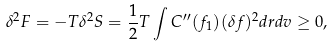Convert formula to latex. <formula><loc_0><loc_0><loc_500><loc_500>\delta ^ { 2 } F = - T \delta ^ { 2 } S = \frac { 1 } { 2 } T \int C ^ { \prime \prime } ( f _ { 1 } ) ( \delta f ) ^ { 2 } d { r } d { v } \geq 0 ,</formula> 